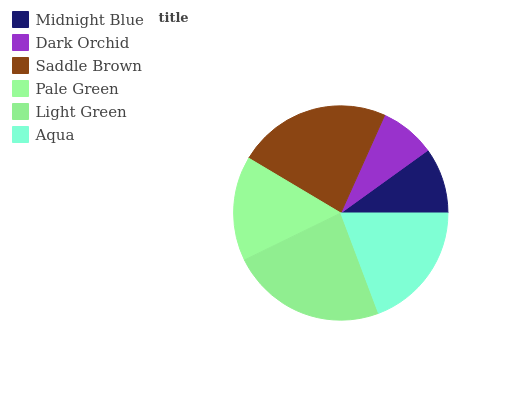Is Dark Orchid the minimum?
Answer yes or no. Yes. Is Light Green the maximum?
Answer yes or no. Yes. Is Saddle Brown the minimum?
Answer yes or no. No. Is Saddle Brown the maximum?
Answer yes or no. No. Is Saddle Brown greater than Dark Orchid?
Answer yes or no. Yes. Is Dark Orchid less than Saddle Brown?
Answer yes or no. Yes. Is Dark Orchid greater than Saddle Brown?
Answer yes or no. No. Is Saddle Brown less than Dark Orchid?
Answer yes or no. No. Is Aqua the high median?
Answer yes or no. Yes. Is Pale Green the low median?
Answer yes or no. Yes. Is Dark Orchid the high median?
Answer yes or no. No. Is Midnight Blue the low median?
Answer yes or no. No. 